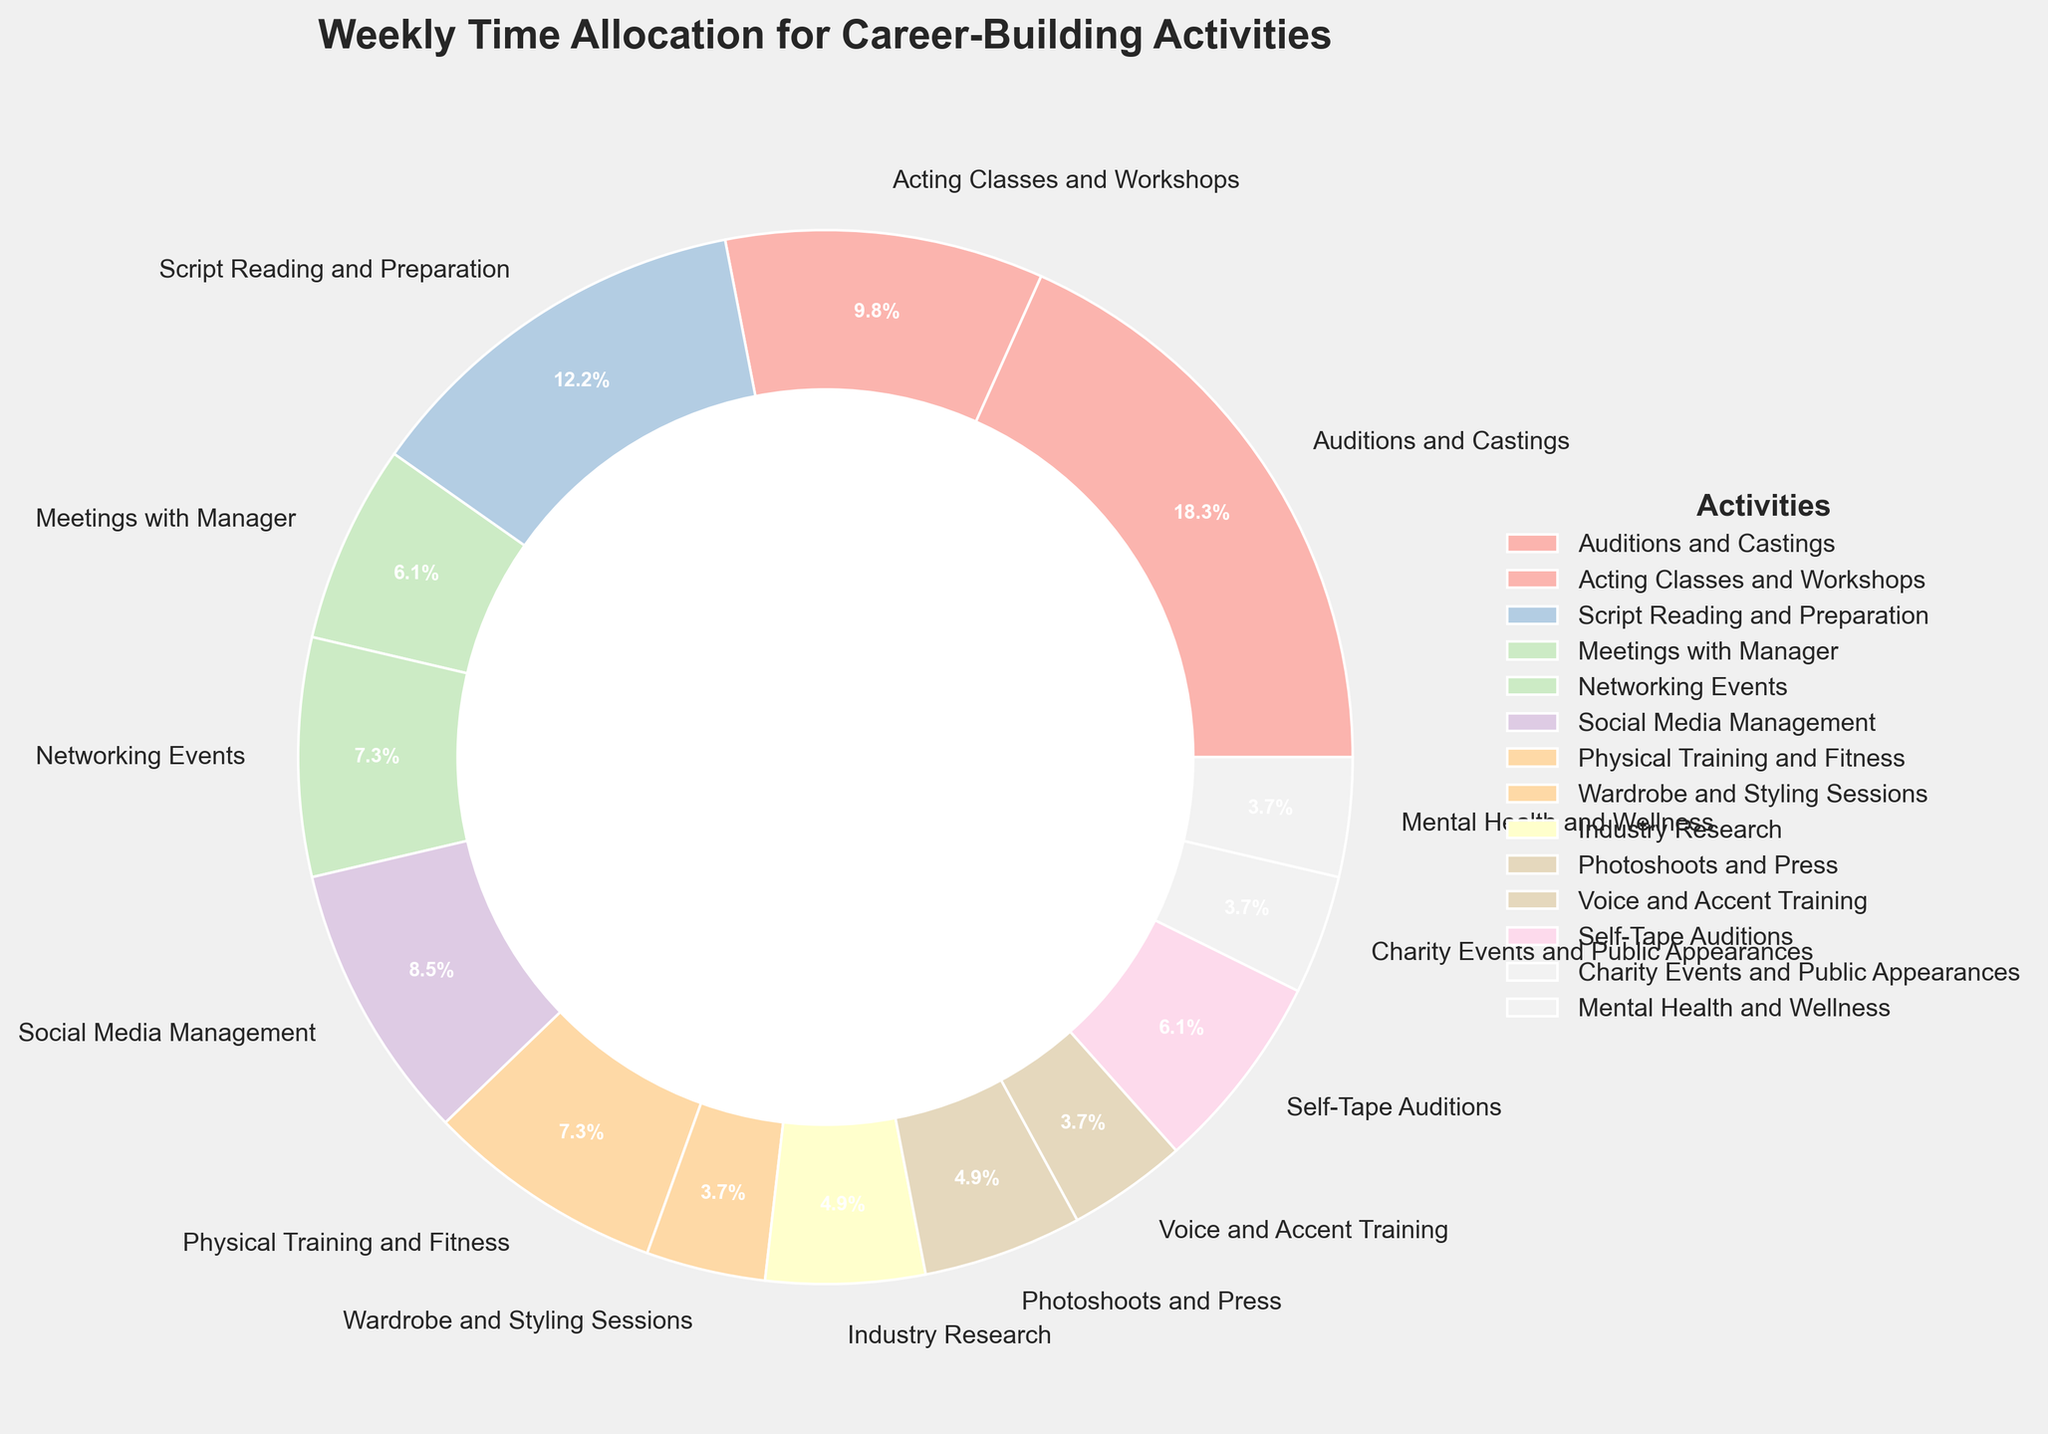Which activity has the highest time allocation? To find the activity with the highest time allocation, look at the largest section of the pie chart and read the corresponding label.
Answer: Auditions and Castings Which two activities take up the least amount of time combined? Identify the two smallest sections of the pie chart and sum up their hours. The smallest sections are those corresponding to Mental Health and Wellness, and Wardrobe and Styling Sessions. Adding these two gives 3 + 3 = 6 hours.
Answer: Mental Health and Wellness and Wardrobe and Styling Sessions How many hours are spent on Social Media Management and Industry Research combined? Find the sections corresponding to Social Media Management (7 hours) and Industry Research (4 hours), then sum them: 7 + 4 = 11 hours.
Answer: 11 hours Which takes more time: Script Reading and Preparation or Physical Training and Fitness? Compare the sizes of the sections corresponding to these activities or read the labels that show the hours: Script Reading and Preparation (10 hours) and Physical Training and Fitness (6 hours).
Answer: Script Reading and Preparation What percentage of the total time is spent on Auditions and Castings? The pie chart shows percentages directly. Find the section for Auditions and Castings and read off the percentage. 15 hours out of a total of 75 hours is calculated as (15/75) * 100 = 20%.
Answer: 20% How many hours in total are spent on Meetings with Manager, Networking Events, and Charity Events and Public Appearances? Add the hours for these activities: Meetings with Manager (5 hours), Networking Events (6 hours), and Charity Events and Public Appearances (3 hours). The total is 5 + 6 + 3 = 14 hours.
Answer: 14 hours Which activities have the same time allocation? Identify the sections of the pie chart with the same size or hours. Mental Health and Wellness, Voice and Accent Training, and Wardrobe and Styling Sessions each have 3 hours.
Answer: Mental Health and Wellness, Voice and Accent Training, and Wardrobe and Styling Sessions Is more time spent on Photoshoots and Press or Voice and Accent Training? Look at their respective sections: Photoshoots and Press (4 hours) and Voice and Accent Training (3 hours).
Answer: Photoshoots and Press How much more time is spent on Acting Classes and Workshops compared to Mental Health and Wellness? Subtract the hours for Mental Health and Wellness (3 hours) from Acting Classes and Workshops (8 hours): 8 - 3 = 5 hours.
Answer: 5 hours If you were to consolidate time spent on Self-Tape Auditions and Meetings with Manager, which activity would you spend more time on? Add the hours for Self-Tape Auditions (5 hours) and Meetings with Manager (5 hours), the total is 10 hours, which matches the hours for Script Reading and Preparation. Script Reading and Preparation also has 10 hours. So neither would surpass it.
Answer: Script Reading and Preparation 